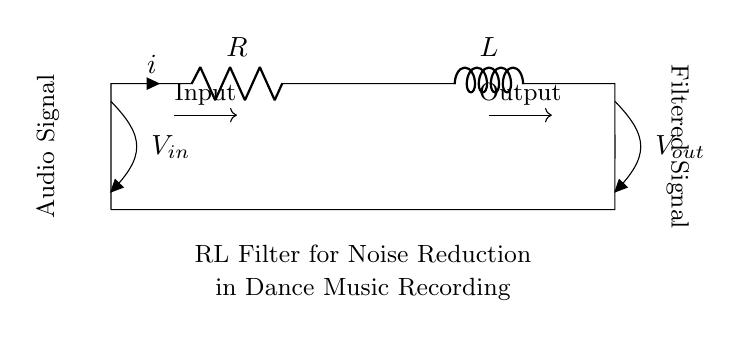What are the two main components in this circuit? The circuit consists of a resistor and an inductor, which are clearly labeled in the diagram. The resistor is represented as R, and the inductor is represented as L.
Answer: Resistor and Inductor What is the function of the circuit? The circuit is designed to filter noise from audio signals, which is indicated in the description below the circuit diagram. It specifies that it is an RL filter for noise reduction in dance music recording.
Answer: Noise reduction in audio signals What is the direction of the current flow in this circuit? The current flow is indicated by the arrows on the circuit diagram, showing that it moves from the input at the top left (Vin) through the components and exits at the output on the top right (Vout).
Answer: From input to output What type of filter does this RL circuit represent? Based on the configuration and components in the diagram, it acts as a low-pass filter, allowing low frequencies to pass while attenuating high frequencies.
Answer: Low-pass filter What are the input and output voltage points labeled as? The input voltage is labeled as V_in at the input side of the circuit, and the output voltage is labeled as V_out at the output side of the circuit, each clearly marked in the diagram.
Answer: V_in and V_out How does the inductor specifically contribute to noise reduction? The inductor allows low-frequency signals to pass while blocking high-frequency noise, contributing to the filtering effect in conjunction with the resistor. This behavior is characteristic of RL circuits.
Answer: By blocking high-frequency noise 